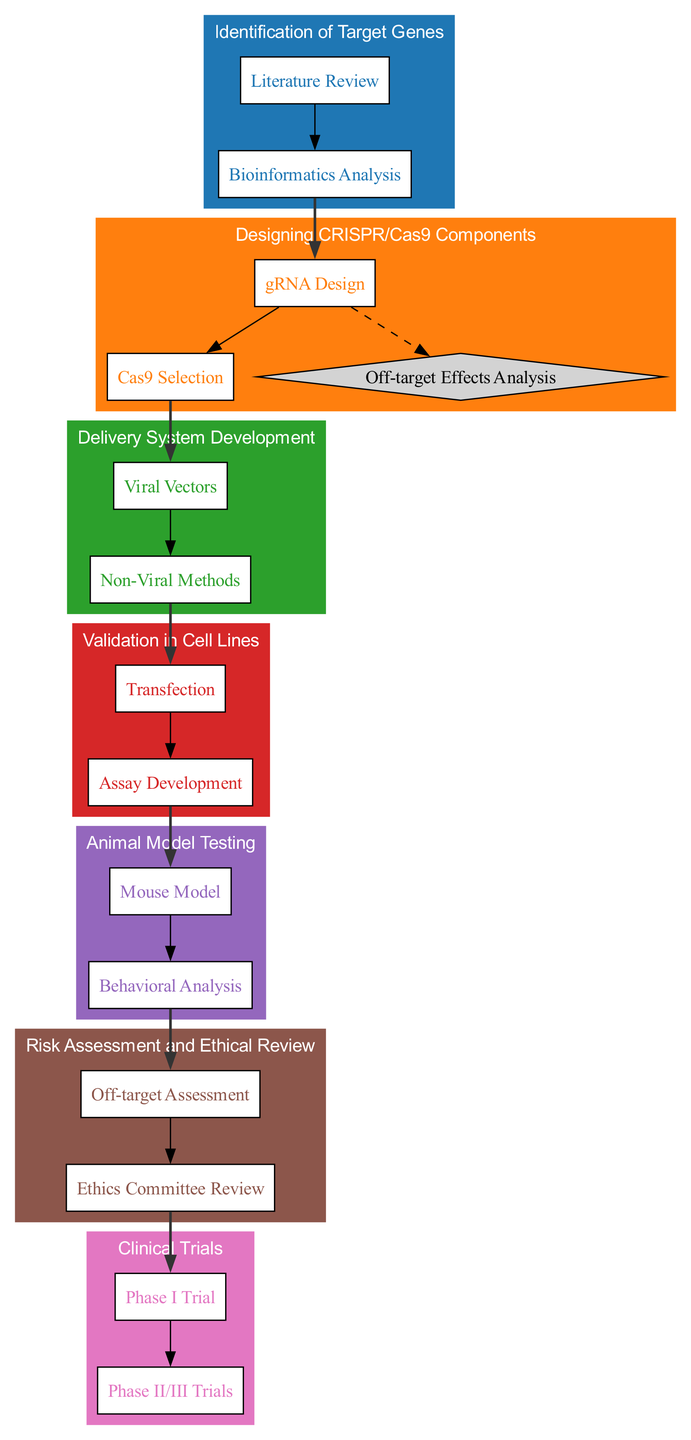What is the first stage in the gene editing workflow? The diagram begins with the "Identification of Target Genes" stage.
Answer: Identification of Target Genes How many actions are involved in the "Delivery System Development" stage? There are two actions listed in the "Delivery System Development" stage: "Viral Vectors" and "Non-Viral Methods."
Answer: 2 What action follows "Assay Development" in the workflow? The action that follows "Assay Development" is "Mouse Model" in the "Animal Model Testing" stage.
Answer: Mouse Model What is the last stage in the gene editing workflow? The last stage is "Clinical Trials."
Answer: Clinical Trials How many decision points are associated with the action "gRNA Design"? There is one decision point associated with the action "gRNA Design."
Answer: 1 Which stage includes the action "Ethics Committee Review"? The action "Ethics Committee Review" is included in the "Risk Assessment and Ethical Review" stage.
Answer: Risk Assessment and Ethical Review What are the two delivery methods listed in the "Delivery System Development" stage? The two delivery methods listed are "Viral Vectors" and "Non-Viral Methods."
Answer: Viral Vectors and Non-Viral Methods Which action must be performed after "Phase I Trial"? The action that must be performed after "Phase I Trial" is "Phase II/III Trials."
Answer: Phase II/III Trials 